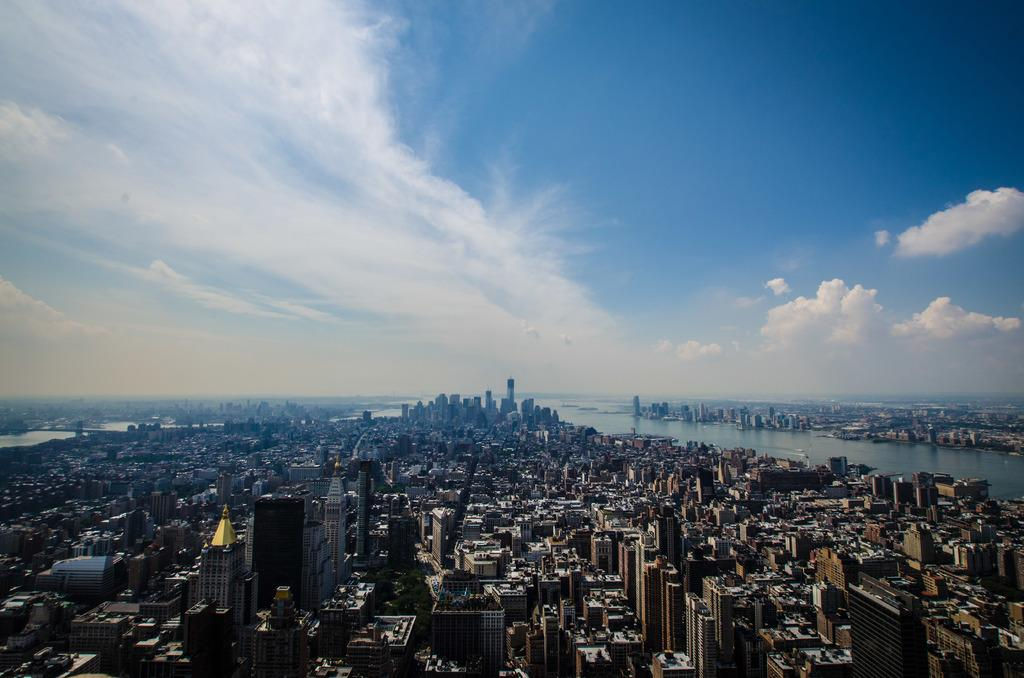What type of location is shown in the image? The image depicts a city. What are some of the prominent features of the city? There are many skyscrapers and buildings in the city. How are people able to travel within the city? There are roads in the city for transportation. What natural feature can be seen on the right side of the image? There is a river on the right side of the image. What is visible at the top of the image? The sky is visible at the top of the image, and clouds are present in the sky. What type of wool is being used to create the light in the image? There is no wool or light present in the image; it depicts a city with skyscrapers, buildings, roads, a river, and clouds in the sky. 